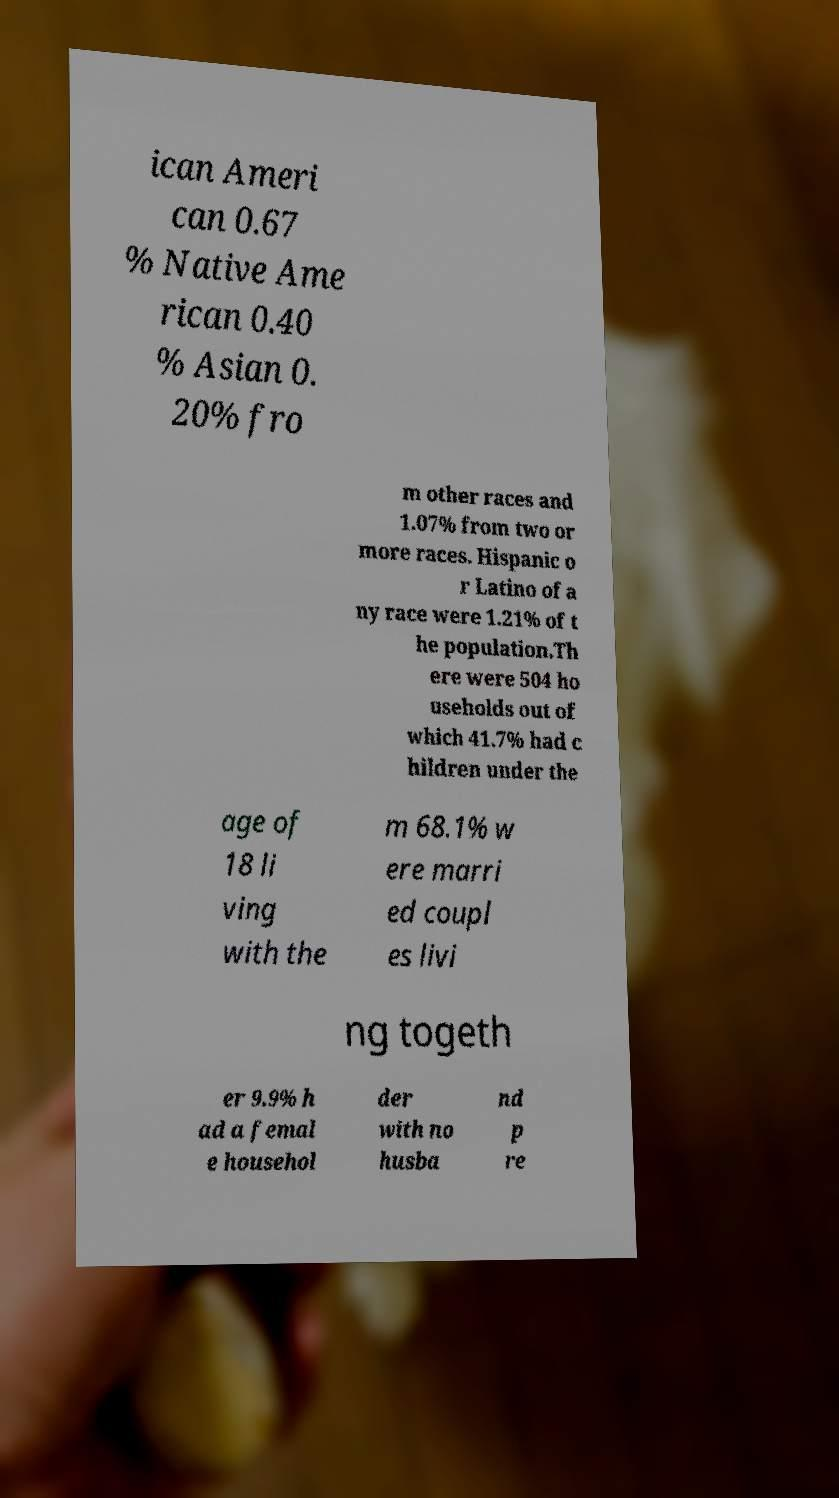Could you extract and type out the text from this image? ican Ameri can 0.67 % Native Ame rican 0.40 % Asian 0. 20% fro m other races and 1.07% from two or more races. Hispanic o r Latino of a ny race were 1.21% of t he population.Th ere were 504 ho useholds out of which 41.7% had c hildren under the age of 18 li ving with the m 68.1% w ere marri ed coupl es livi ng togeth er 9.9% h ad a femal e househol der with no husba nd p re 